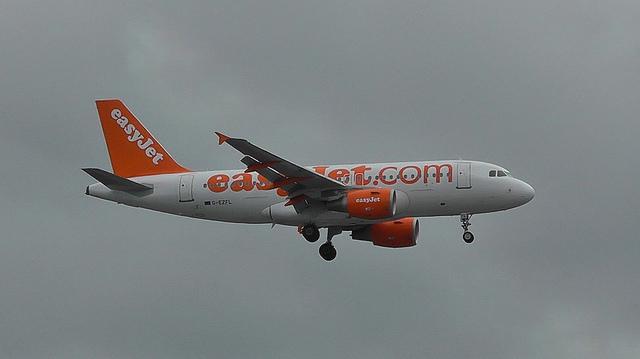Is the aircraft taking off or preparing to land?
Write a very short answer. Land. What colors is the plane?
Concise answer only. White and orange. What color is the plane?
Short answer required. White and orange. What word is on the plane?
Give a very brief answer. Easyjet. 